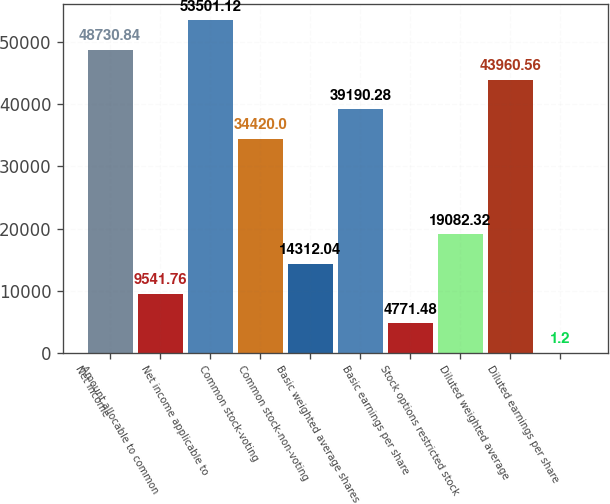Convert chart. <chart><loc_0><loc_0><loc_500><loc_500><bar_chart><fcel>Net income<fcel>Amount allocable to common<fcel>Net income applicable to<fcel>Common stock-voting<fcel>Common stock-non-voting<fcel>Basic weighted average shares<fcel>Basic earnings per share<fcel>Stock options restricted stock<fcel>Diluted weighted average<fcel>Diluted earnings per share<nl><fcel>48730.8<fcel>9541.76<fcel>53501.1<fcel>34420<fcel>14312<fcel>39190.3<fcel>4771.48<fcel>19082.3<fcel>43960.6<fcel>1.2<nl></chart> 